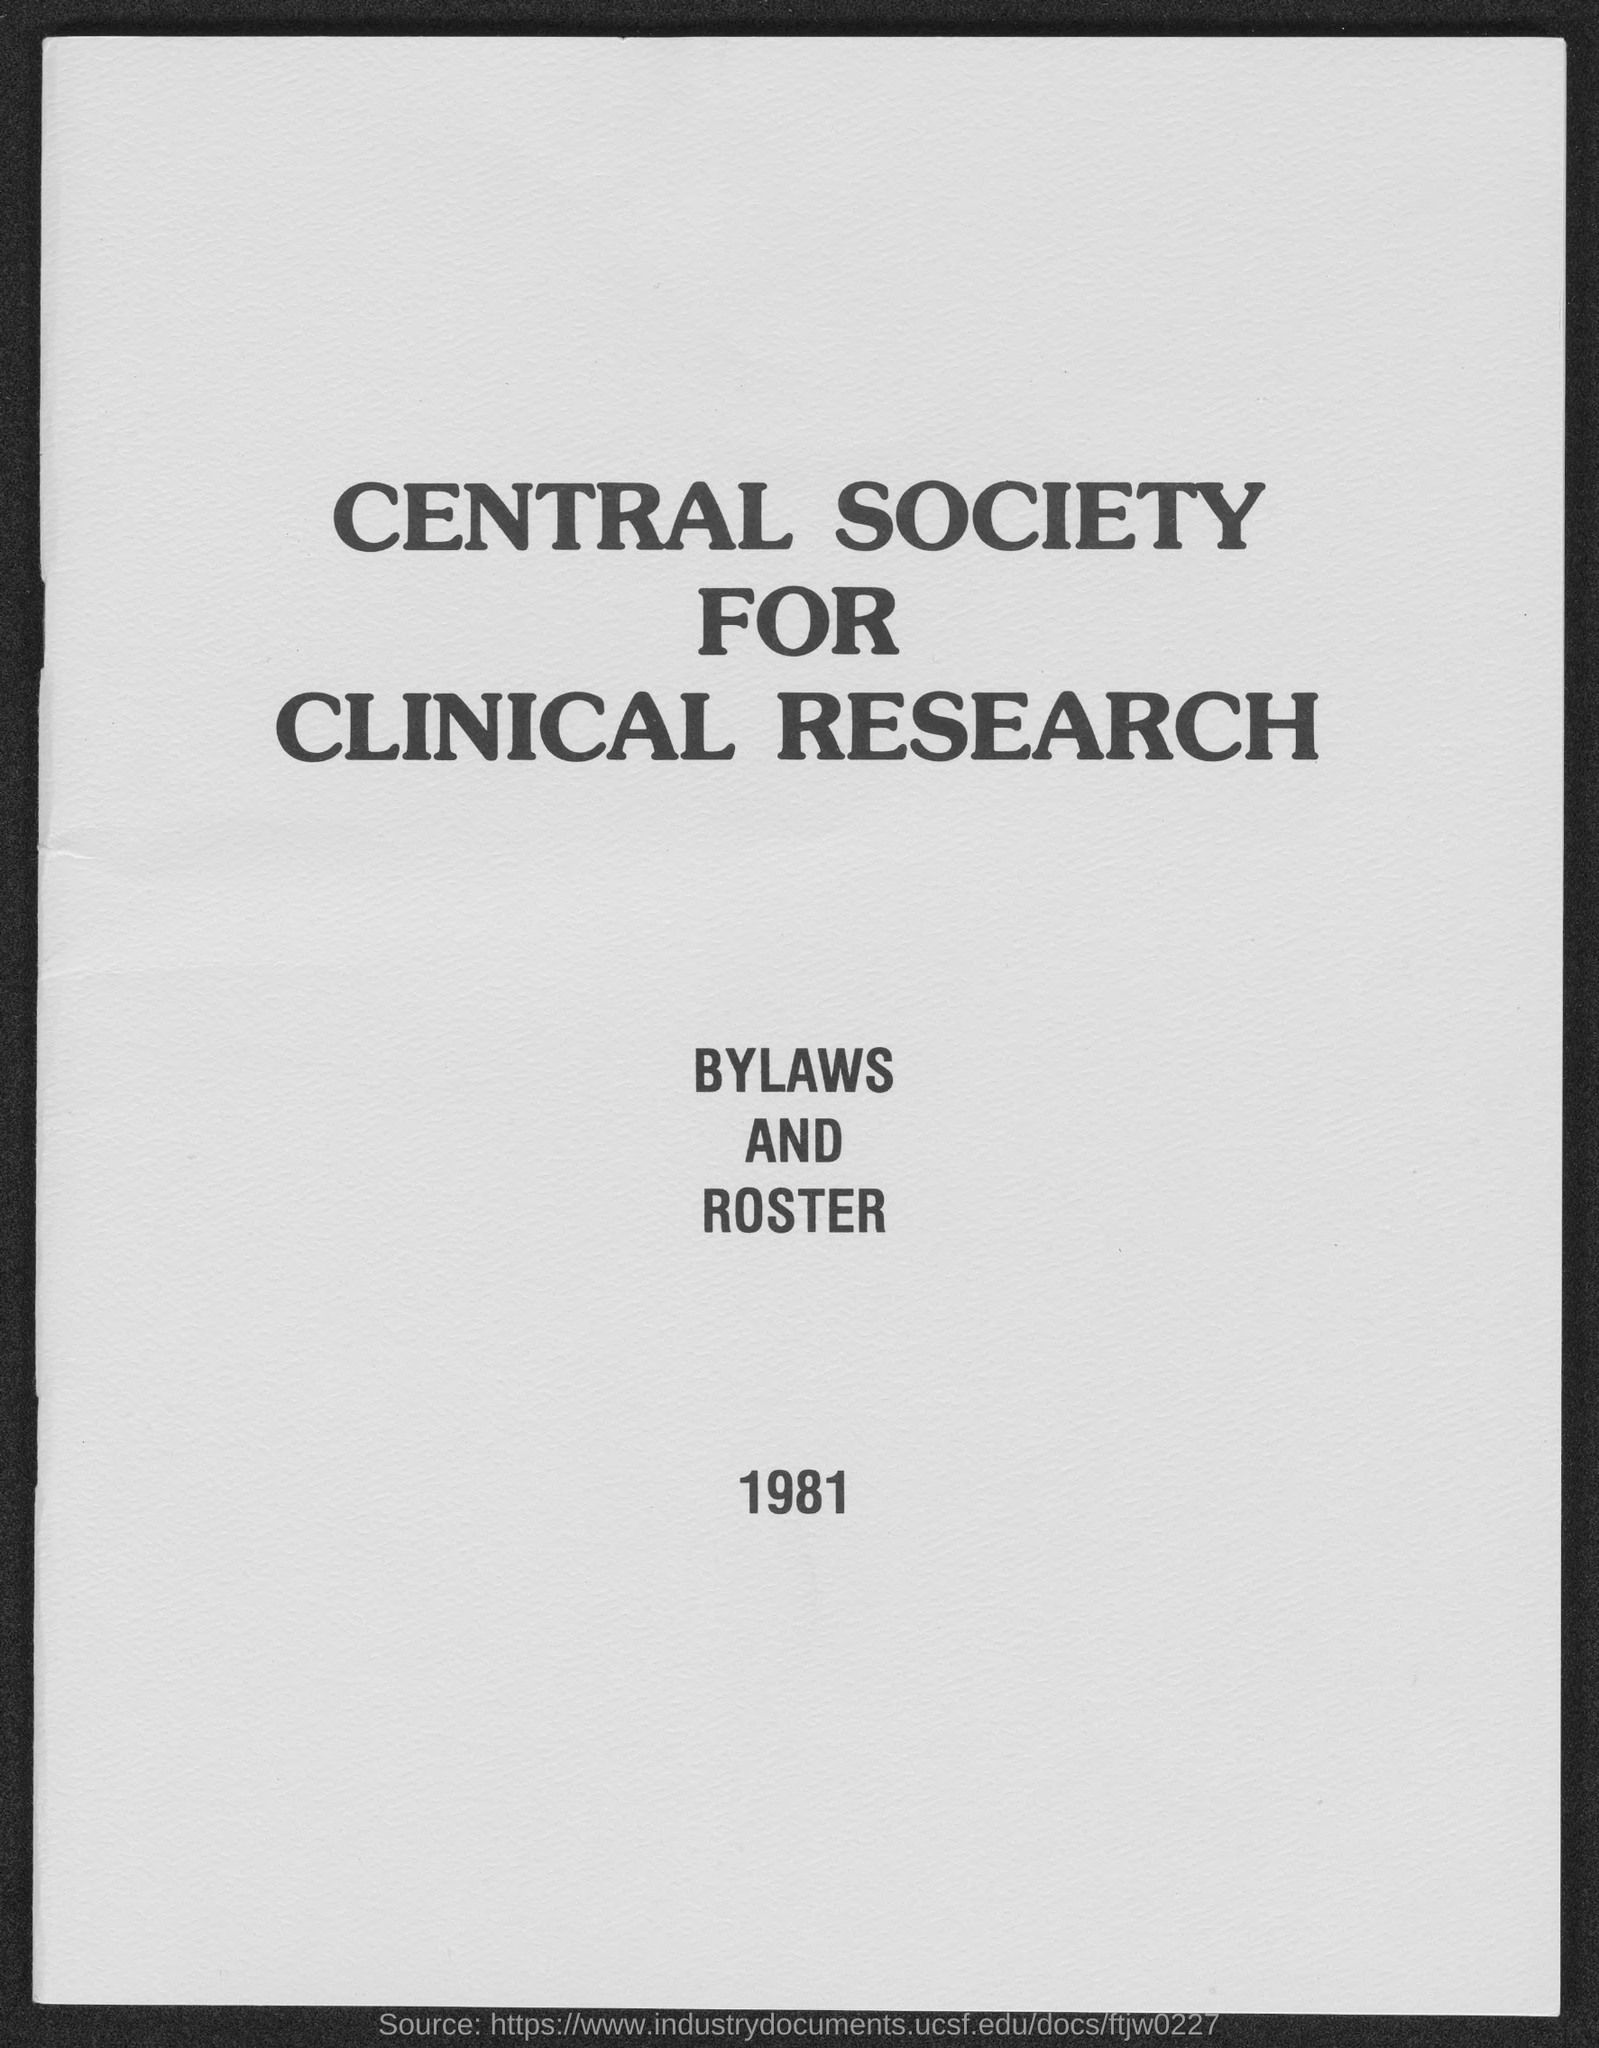What is the year mentioned in page?
Provide a short and direct response. 1981. What is the central society for?
Provide a short and direct response. Clinical Research. 